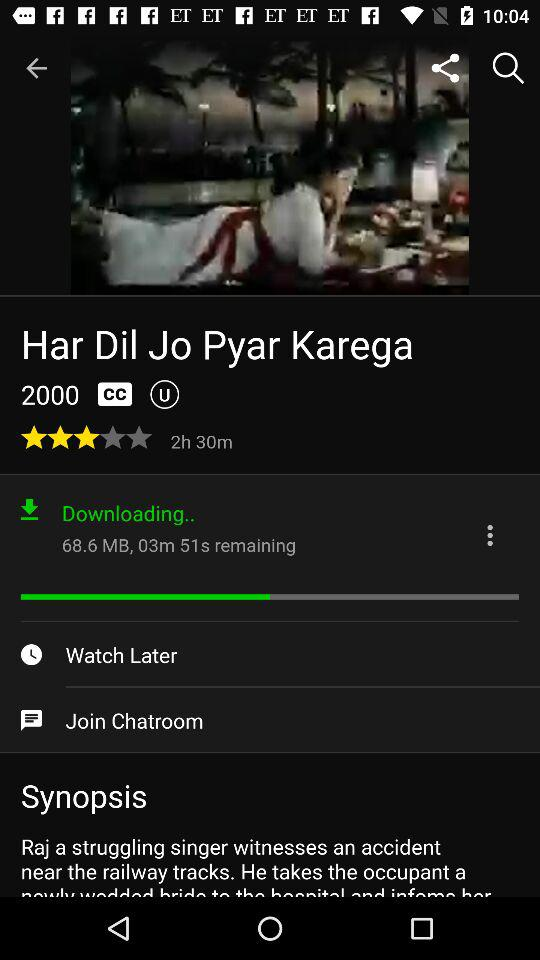In what year was the movie "Har Dil Jo Pyar Karega" released? The movie "Har Dil Jo Pyar Krega" was released in 2000. 